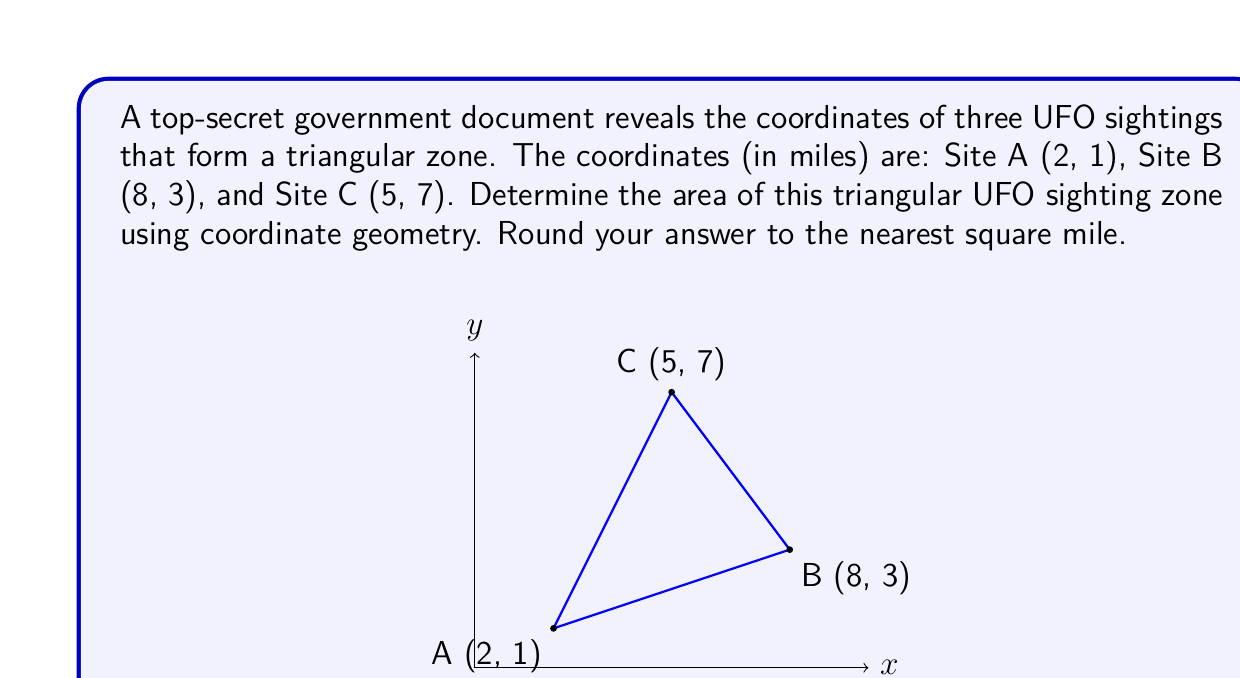Provide a solution to this math problem. To find the area of the triangular UFO sighting zone, we can use the formula derived from the coordinates of the three points:

$$\text{Area} = \frac{1}{2}|x_1(y_2 - y_3) + x_2(y_3 - y_1) + x_3(y_1 - y_2)|$$

Where $(x_1, y_1)$, $(x_2, y_2)$, and $(x_3, y_3)$ are the coordinates of the three points.

Let's plug in our coordinates:
* A: $(x_1, y_1) = (2, 1)$
* B: $(x_2, y_2) = (8, 3)$
* C: $(x_3, y_3) = (5, 7)$

Now, let's calculate:

$$\begin{align*}
\text{Area} &= \frac{1}{2}|2(3 - 7) + 8(7 - 1) + 5(1 - 3)|\\
&= \frac{1}{2}|2(-4) + 8(6) + 5(-2)|\\
&= \frac{1}{2}|-8 + 48 - 10|\\
&= \frac{1}{2}|30|\\
&= \frac{1}{2}(30)\\
&= 15
\end{align*}$$

Therefore, the area of the triangular UFO sighting zone is 15 square miles.
Answer: 15 square miles 